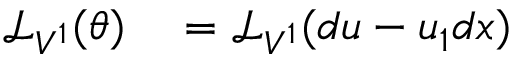Convert formula to latex. <formula><loc_0><loc_0><loc_500><loc_500>\begin{array} { r l r l } { { \mathcal { L } } _ { V ^ { 1 } } ( \theta ) } & = { \mathcal { L } } _ { V ^ { 1 } } ( d u - u _ { 1 } d x ) } \end{array}</formula> 